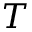Convert formula to latex. <formula><loc_0><loc_0><loc_500><loc_500>T</formula> 